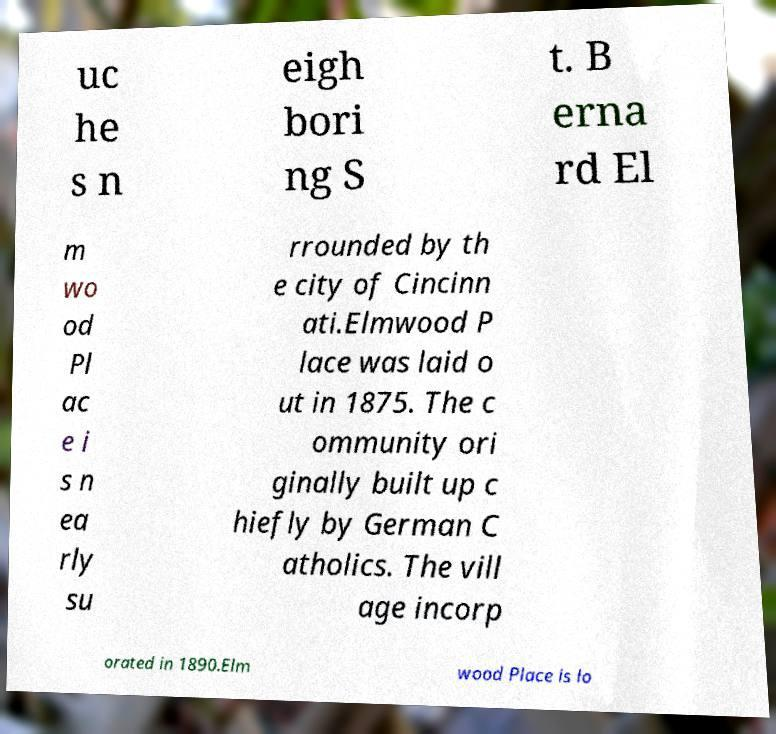Could you assist in decoding the text presented in this image and type it out clearly? uc he s n eigh bori ng S t. B erna rd El m wo od Pl ac e i s n ea rly su rrounded by th e city of Cincinn ati.Elmwood P lace was laid o ut in 1875. The c ommunity ori ginally built up c hiefly by German C atholics. The vill age incorp orated in 1890.Elm wood Place is lo 